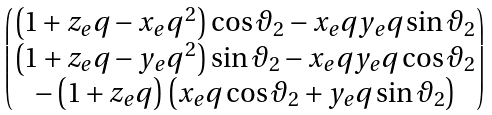Convert formula to latex. <formula><loc_0><loc_0><loc_500><loc_500>\begin{pmatrix} \left ( 1 + z _ { e } q - x _ { e } q ^ { \, 2 } \right ) \cos \vartheta _ { 2 } - x _ { e } q y _ { e } q \sin \vartheta _ { 2 } \\ \left ( 1 + z _ { e } q - y _ { e } q ^ { \, 2 } \right ) \sin \vartheta _ { 2 } - x _ { e } q y _ { e } q \cos \vartheta _ { 2 } \\ - \left ( 1 + z _ { e } q \right ) \left ( x _ { e } q \cos \vartheta _ { 2 } + y _ { e } q \sin \vartheta _ { 2 } \right ) \end{pmatrix}</formula> 